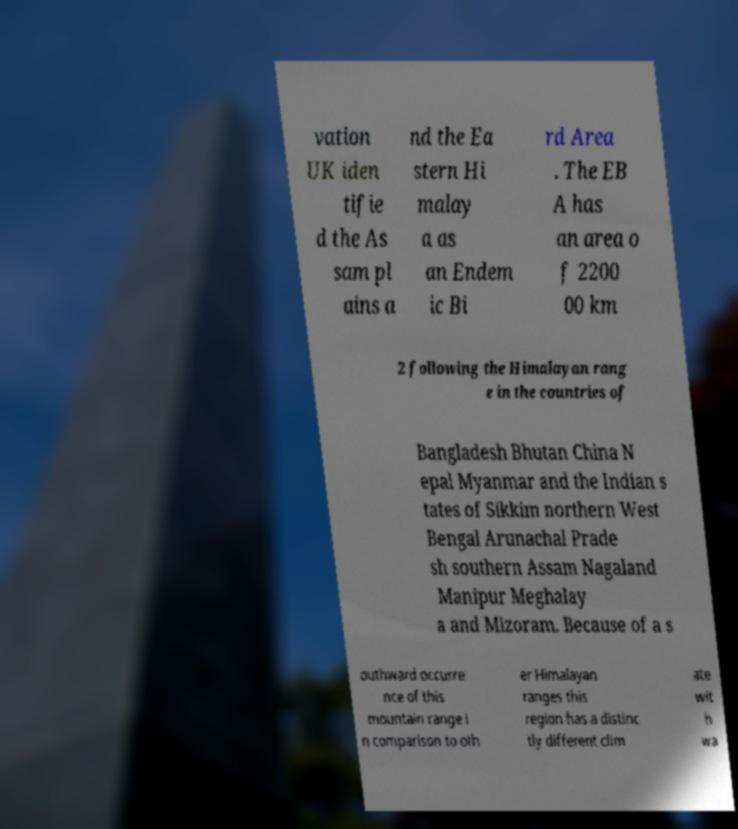There's text embedded in this image that I need extracted. Can you transcribe it verbatim? vation UK iden tifie d the As sam pl ains a nd the Ea stern Hi malay a as an Endem ic Bi rd Area . The EB A has an area o f 2200 00 km 2 following the Himalayan rang e in the countries of Bangladesh Bhutan China N epal Myanmar and the Indian s tates of Sikkim northern West Bengal Arunachal Prade sh southern Assam Nagaland Manipur Meghalay a and Mizoram. Because of a s outhward occurre nce of this mountain range i n comparison to oth er Himalayan ranges this region has a distinc tly different clim ate wit h wa 